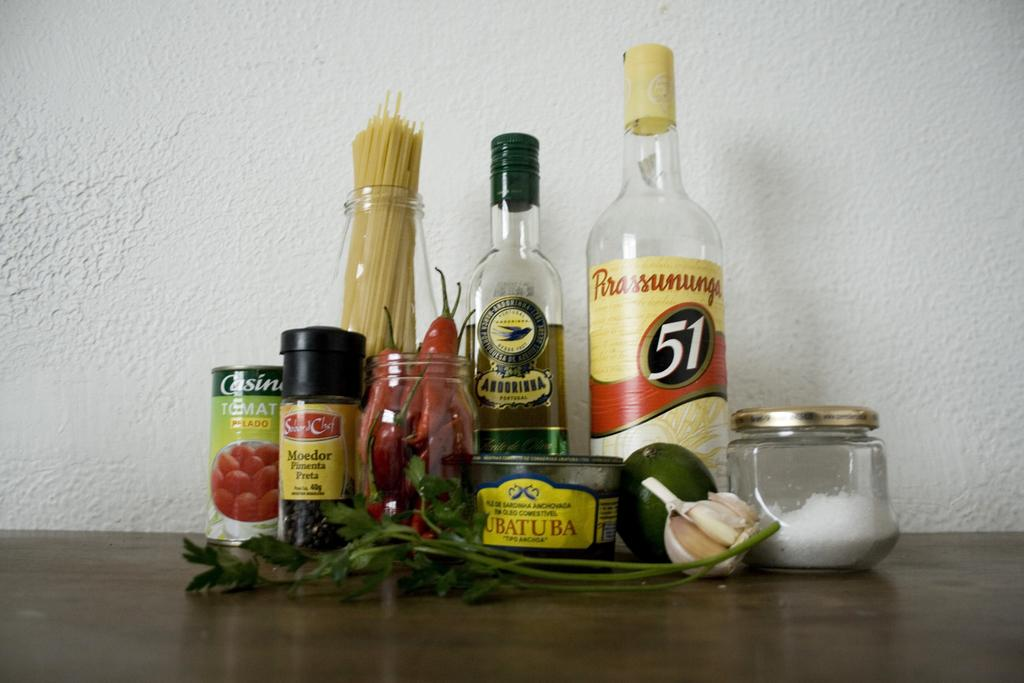How many bottles can be seen in the image? There are two bottles in the image. What other types of containers are present in the image? There are jars in the image. Can you describe any other objects in the image besides the bottles and jars? There are a few other unspecified objects in the image. What type of ray is visible in the image? There is no ray present in the image. 